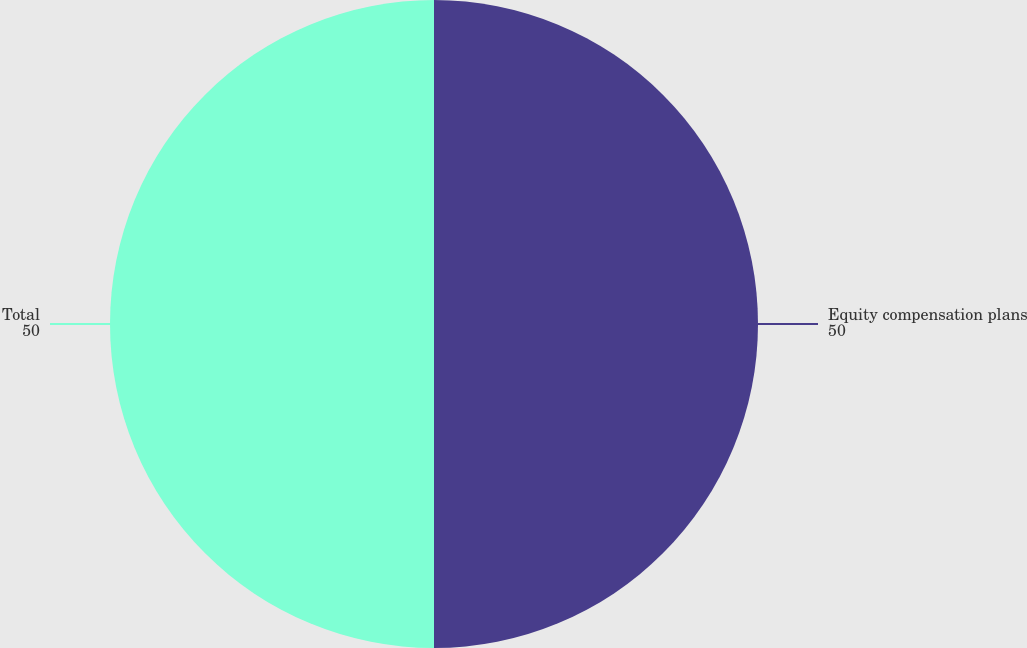Convert chart. <chart><loc_0><loc_0><loc_500><loc_500><pie_chart><fcel>Equity compensation plans<fcel>Total<nl><fcel>50.0%<fcel>50.0%<nl></chart> 